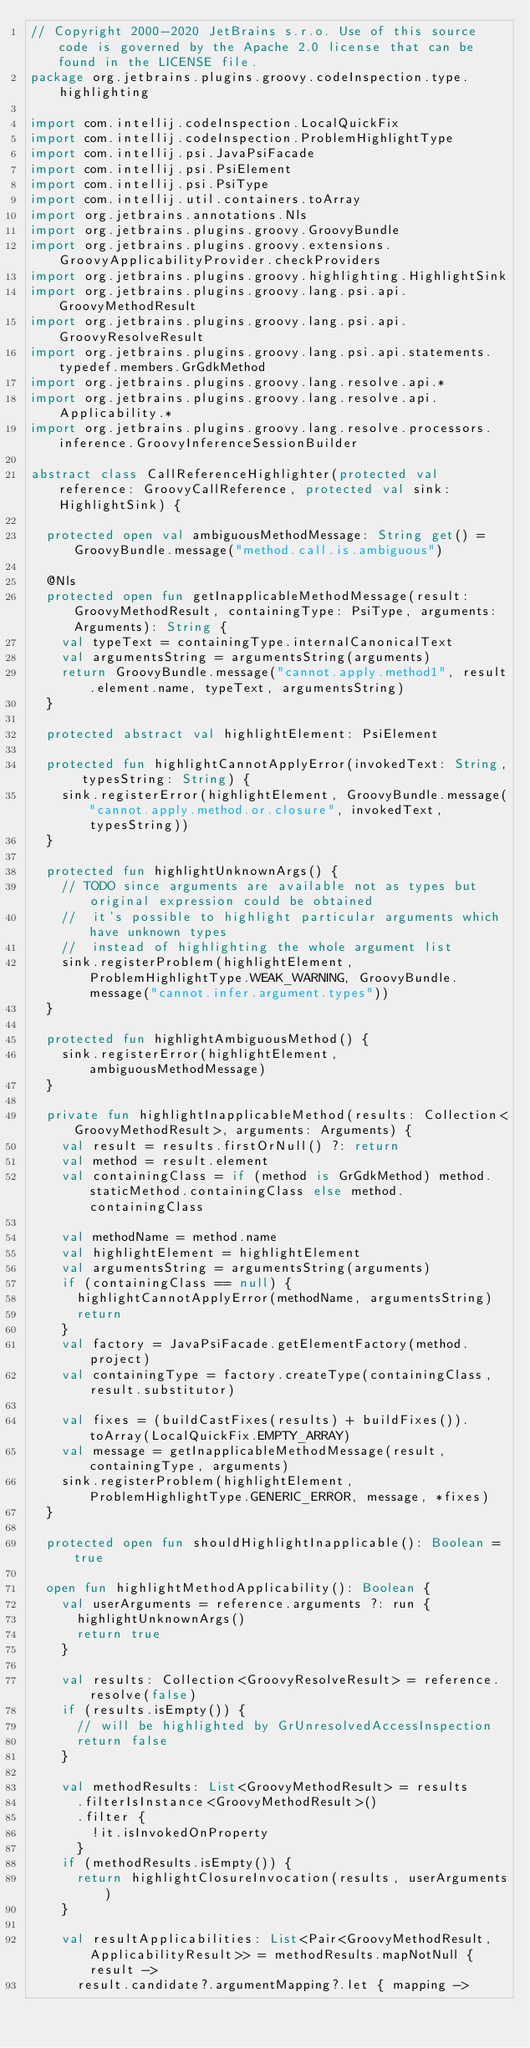Convert code to text. <code><loc_0><loc_0><loc_500><loc_500><_Kotlin_>// Copyright 2000-2020 JetBrains s.r.o. Use of this source code is governed by the Apache 2.0 license that can be found in the LICENSE file.
package org.jetbrains.plugins.groovy.codeInspection.type.highlighting

import com.intellij.codeInspection.LocalQuickFix
import com.intellij.codeInspection.ProblemHighlightType
import com.intellij.psi.JavaPsiFacade
import com.intellij.psi.PsiElement
import com.intellij.psi.PsiType
import com.intellij.util.containers.toArray
import org.jetbrains.annotations.Nls
import org.jetbrains.plugins.groovy.GroovyBundle
import org.jetbrains.plugins.groovy.extensions.GroovyApplicabilityProvider.checkProviders
import org.jetbrains.plugins.groovy.highlighting.HighlightSink
import org.jetbrains.plugins.groovy.lang.psi.api.GroovyMethodResult
import org.jetbrains.plugins.groovy.lang.psi.api.GroovyResolveResult
import org.jetbrains.plugins.groovy.lang.psi.api.statements.typedef.members.GrGdkMethod
import org.jetbrains.plugins.groovy.lang.resolve.api.*
import org.jetbrains.plugins.groovy.lang.resolve.api.Applicability.*
import org.jetbrains.plugins.groovy.lang.resolve.processors.inference.GroovyInferenceSessionBuilder

abstract class CallReferenceHighlighter(protected val reference: GroovyCallReference, protected val sink: HighlightSink) {

  protected open val ambiguousMethodMessage: String get() = GroovyBundle.message("method.call.is.ambiguous")

  @Nls
  protected open fun getInapplicableMethodMessage(result: GroovyMethodResult, containingType: PsiType, arguments: Arguments): String {
    val typeText = containingType.internalCanonicalText
    val argumentsString = argumentsString(arguments)
    return GroovyBundle.message("cannot.apply.method1", result.element.name, typeText, argumentsString)
  }

  protected abstract val highlightElement: PsiElement

  protected fun highlightCannotApplyError(invokedText: String, typesString: String) {
    sink.registerError(highlightElement, GroovyBundle.message("cannot.apply.method.or.closure", invokedText, typesString))
  }

  protected fun highlightUnknownArgs() {
    // TODO since arguments are available not as types but original expression could be obtained
    //  it's possible to highlight particular arguments which have unknown types
    //  instead of highlighting the whole argument list
    sink.registerProblem(highlightElement, ProblemHighlightType.WEAK_WARNING, GroovyBundle.message("cannot.infer.argument.types"))
  }

  protected fun highlightAmbiguousMethod() {
    sink.registerError(highlightElement, ambiguousMethodMessage)
  }

  private fun highlightInapplicableMethod(results: Collection<GroovyMethodResult>, arguments: Arguments) {
    val result = results.firstOrNull() ?: return
    val method = result.element
    val containingClass = if (method is GrGdkMethod) method.staticMethod.containingClass else method.containingClass

    val methodName = method.name
    val highlightElement = highlightElement
    val argumentsString = argumentsString(arguments)
    if (containingClass == null) {
      highlightCannotApplyError(methodName, argumentsString)
      return
    }
    val factory = JavaPsiFacade.getElementFactory(method.project)
    val containingType = factory.createType(containingClass, result.substitutor)

    val fixes = (buildCastFixes(results) + buildFixes()).toArray(LocalQuickFix.EMPTY_ARRAY)
    val message = getInapplicableMethodMessage(result, containingType, arguments)
    sink.registerProblem(highlightElement, ProblemHighlightType.GENERIC_ERROR, message, *fixes)
  }

  protected open fun shouldHighlightInapplicable(): Boolean = true

  open fun highlightMethodApplicability(): Boolean {
    val userArguments = reference.arguments ?: run {
      highlightUnknownArgs()
      return true
    }

    val results: Collection<GroovyResolveResult> = reference.resolve(false)
    if (results.isEmpty()) {
      // will be highlighted by GrUnresolvedAccessInspection
      return false
    }

    val methodResults: List<GroovyMethodResult> = results
      .filterIsInstance<GroovyMethodResult>()
      .filter {
        !it.isInvokedOnProperty
      }
    if (methodResults.isEmpty()) {
      return highlightClosureInvocation(results, userArguments)
    }

    val resultApplicabilities: List<Pair<GroovyMethodResult, ApplicabilityResult>> = methodResults.mapNotNull { result ->
      result.candidate?.argumentMapping?.let { mapping -></code> 